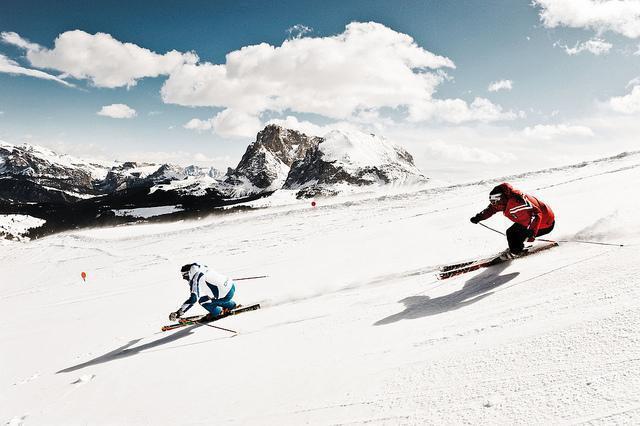What kind of skis are the two using in this mountain range?
Select the accurate response from the four choices given to answer the question.
Options: Country, racing, alpine, trick. Racing. 